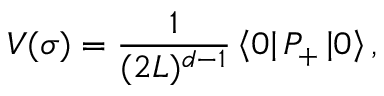<formula> <loc_0><loc_0><loc_500><loc_500>V ( \sigma ) = { \frac { 1 } { ( 2 L ) ^ { d - 1 } } } \left \langle 0 \right | P _ { + } \left | 0 \right \rangle ,</formula> 